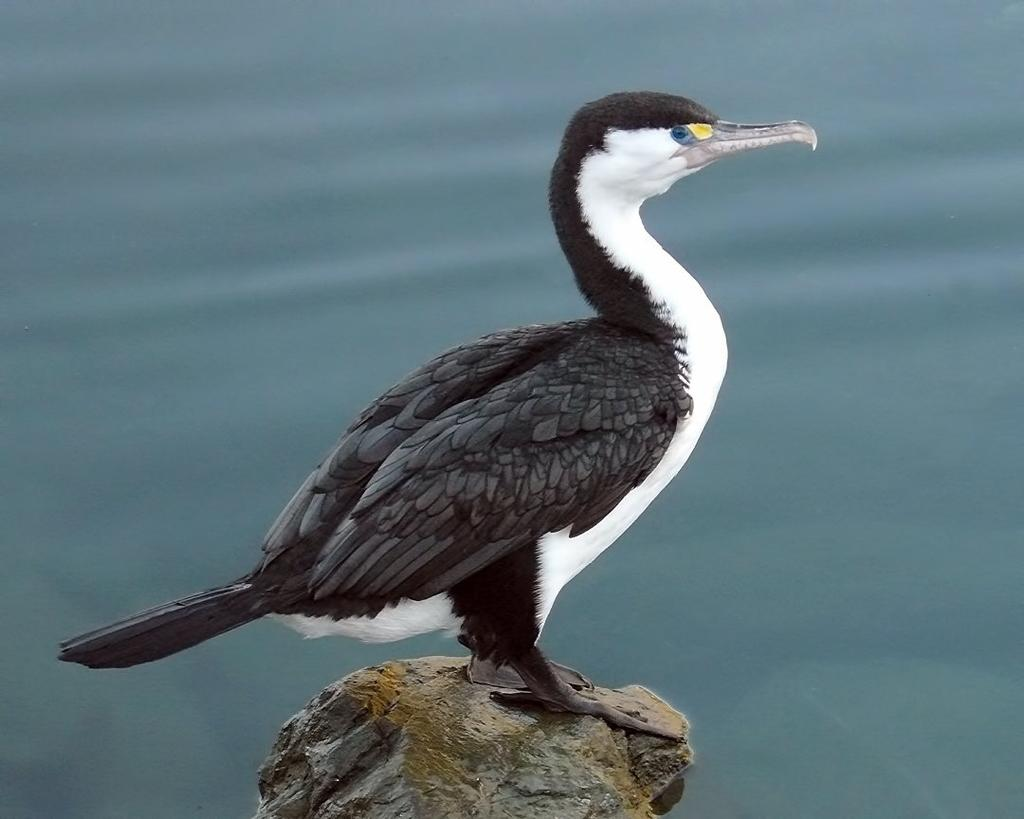What type of animal is in the image? There is a bird in the image. Where is the bird located? The bird is on a rock. What can be seen in the background of the image? There is water visible in the background of the image. What is the rate of the bird's magical transformation in the image? There is no mention of magic or transformation in the image; it simply shows a bird on a rock with water in the background. 